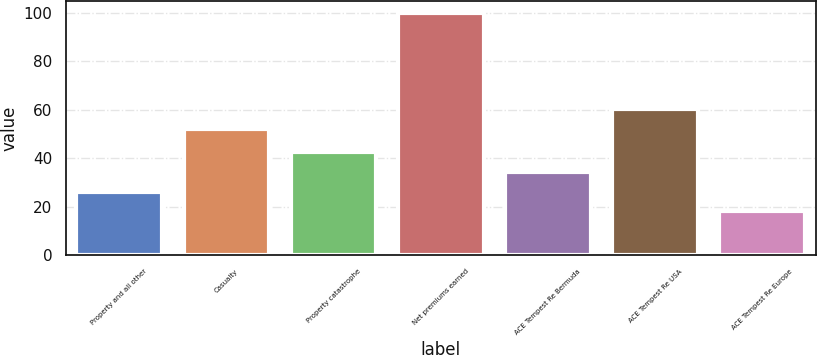Convert chart to OTSL. <chart><loc_0><loc_0><loc_500><loc_500><bar_chart><fcel>Property and all other<fcel>Casualty<fcel>Property catastrophe<fcel>Net premiums earned<fcel>ACE Tempest Re Bermuda<fcel>ACE Tempest Re USA<fcel>ACE Tempest Re Europe<nl><fcel>26.2<fcel>52<fcel>42.6<fcel>100<fcel>34.4<fcel>60.2<fcel>18<nl></chart> 